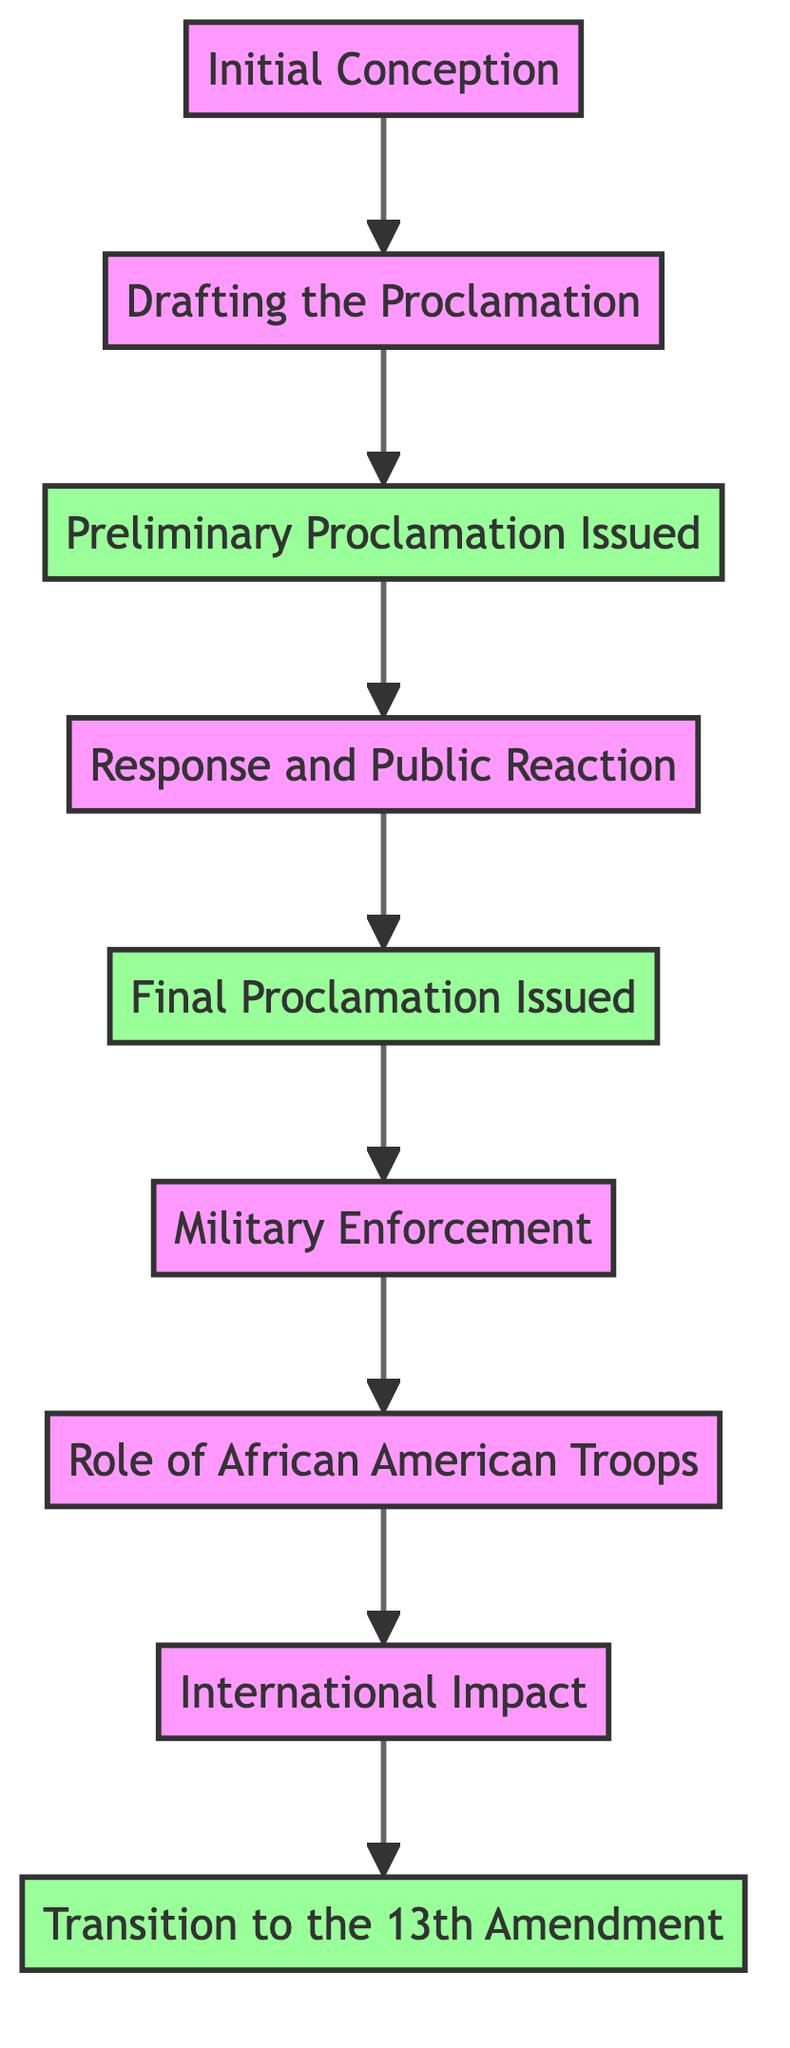What is the first stage of the cycle? The diagram clearly indicates that the first stage is "Initial Conception," which is placed at the top of the flowchart.
Answer: Initial Conception How many milestones are present in the diagram? By reviewing the flowchart, we can see there are three nodes distinctly labeled as milestones, which are "Preliminary Proclamation Issued," "Final Proclamation Issued," and "Transition to the 13th Amendment."
Answer: 3 Which stage follows the "Response and Public Reaction"? Looking at the flow of the diagram, the stage that directly follows "Response and Public Reaction" is "Final Proclamation Issued," as indicated by the flow from node D to node E.
Answer: Final Proclamation Issued What role did African American troops play according to the diagram? The diagram specifies that the "Role of African American Troops" mentions that the proclamation allowed for their enlistment, which directly contributed to boosting manpower and morale in the Union Army.
Answer: Boosting manpower and morale What is the relationship between the "Final Proclamation Issued" and "Military Enforcement"? According to the flowchart structure, "Final Proclamation Issued" leads into "Military Enforcement," indicating that the issuance of the proclamation initiated the enforcement actions taken by the Union Army.
Answer: Initiated enforcement actions What is the significance of the timeline in the proclamation stages? The timeline, as depicted in the flowchart, shows the progression of events from conception to the transition to the 13th Amendment, demonstrating the evolution of the Emancipation Proclamation's impact over time.
Answer: Demonstrating evolution over time Do any stages have the same direct predecessor? Viewing the flowchart, we note that "Military Enforcement" and "Role of African American Troops" both follow the milestone of "Final Proclamation Issued," sharing this common predecessor.
Answer: Final Proclamation Issued What does the "International Impact" stage highlight? In the diagram, the "International Impact" stage emphasizes the diplomatic reinforcement with anti-slavery countries like Britain and France and how the proclamation deterred them from supporting the Confederacy.
Answer: Diplomatic reinforcement Which two key figures were involved in drafting the Emancipation Proclamation? The flowchart directly mentions that President Abraham Lincoln collaborated with Secretaries William H. Seward and Edwin M. Stanton during the drafting process, highlighting their key roles.
Answer: Lincoln, Seward, and Stanton 